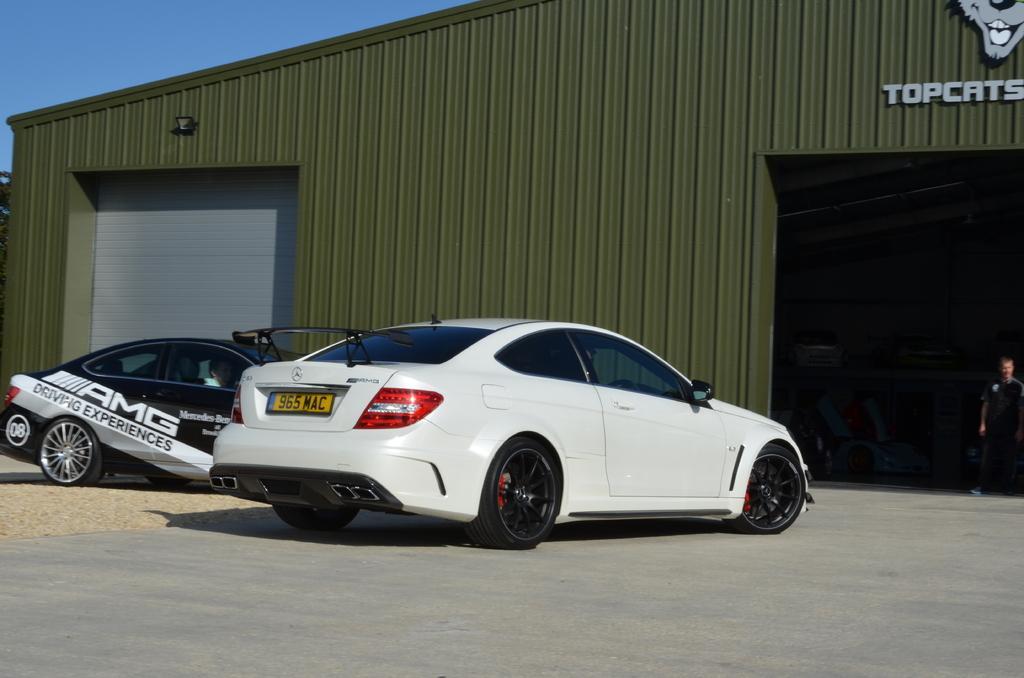Describe this image in one or two sentences. In this picture, we see two cars which are in white and black color are parked on the road. At the bottom, we see the road. On the right side, we see a man in black T-shirt is standing. Behind him, we see a cottage in green color. In the right top, we see some text written on it. In the left top, we see the sky. 